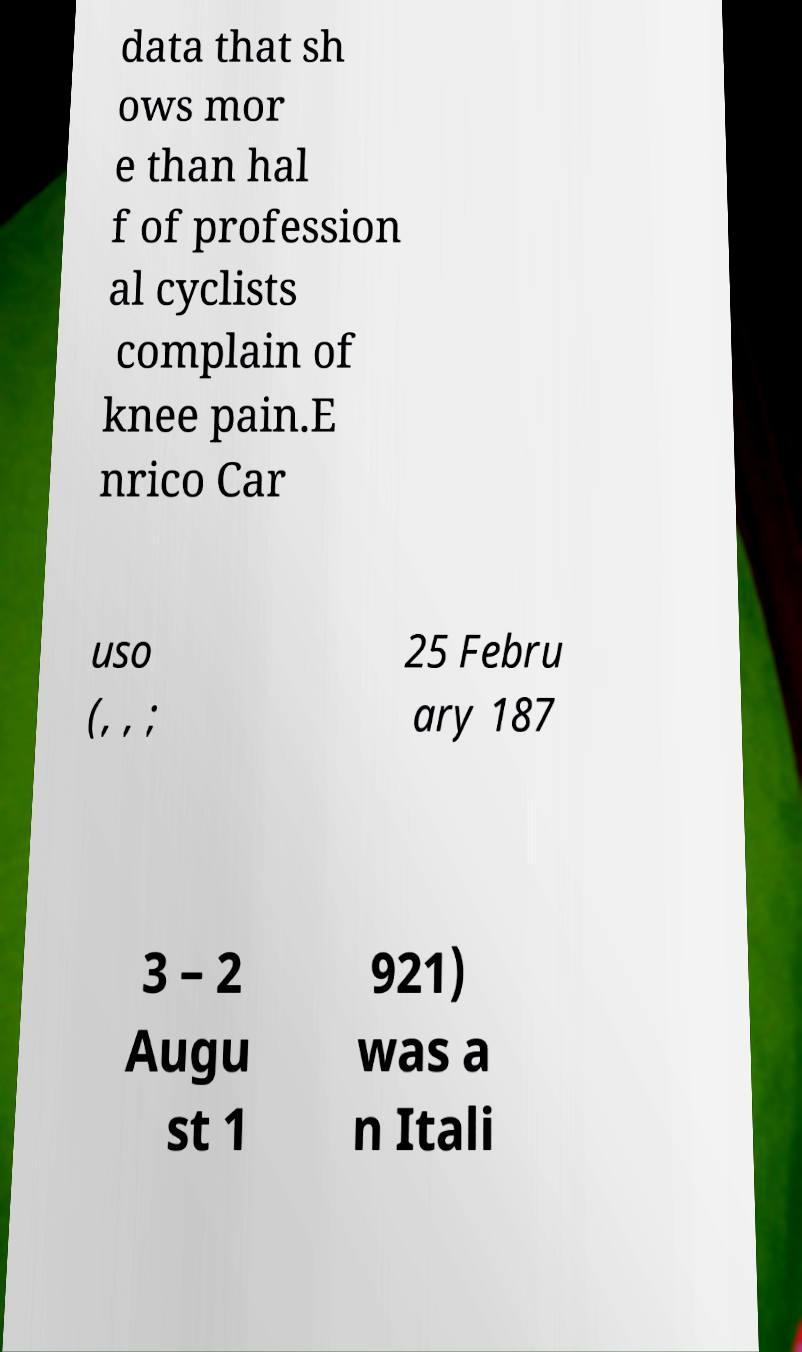For documentation purposes, I need the text within this image transcribed. Could you provide that? data that sh ows mor e than hal f of profession al cyclists complain of knee pain.E nrico Car uso (, , ; 25 Febru ary 187 3 – 2 Augu st 1 921) was a n Itali 